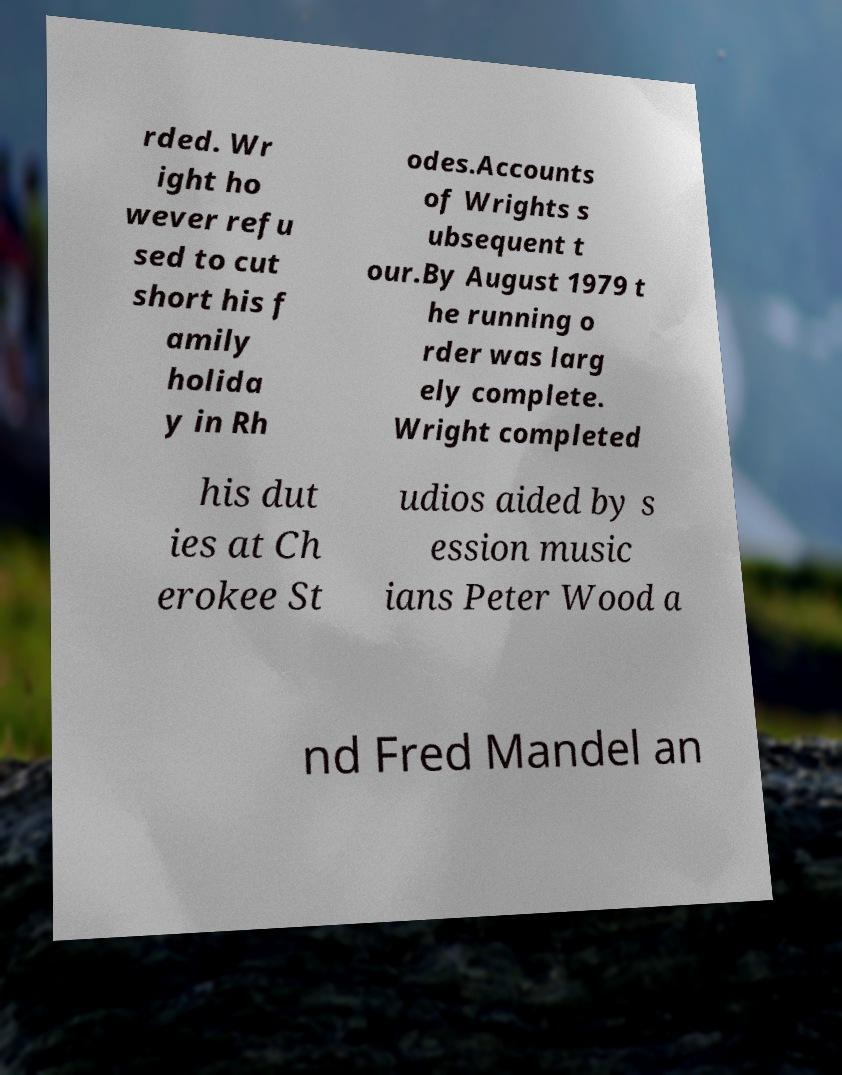Please read and relay the text visible in this image. What does it say? rded. Wr ight ho wever refu sed to cut short his f amily holida y in Rh odes.Accounts of Wrights s ubsequent t our.By August 1979 t he running o rder was larg ely complete. Wright completed his dut ies at Ch erokee St udios aided by s ession music ians Peter Wood a nd Fred Mandel an 